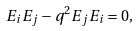<formula> <loc_0><loc_0><loc_500><loc_500>E _ { i } E _ { j } - q ^ { 2 } E _ { j } E _ { i } = 0 ,</formula> 